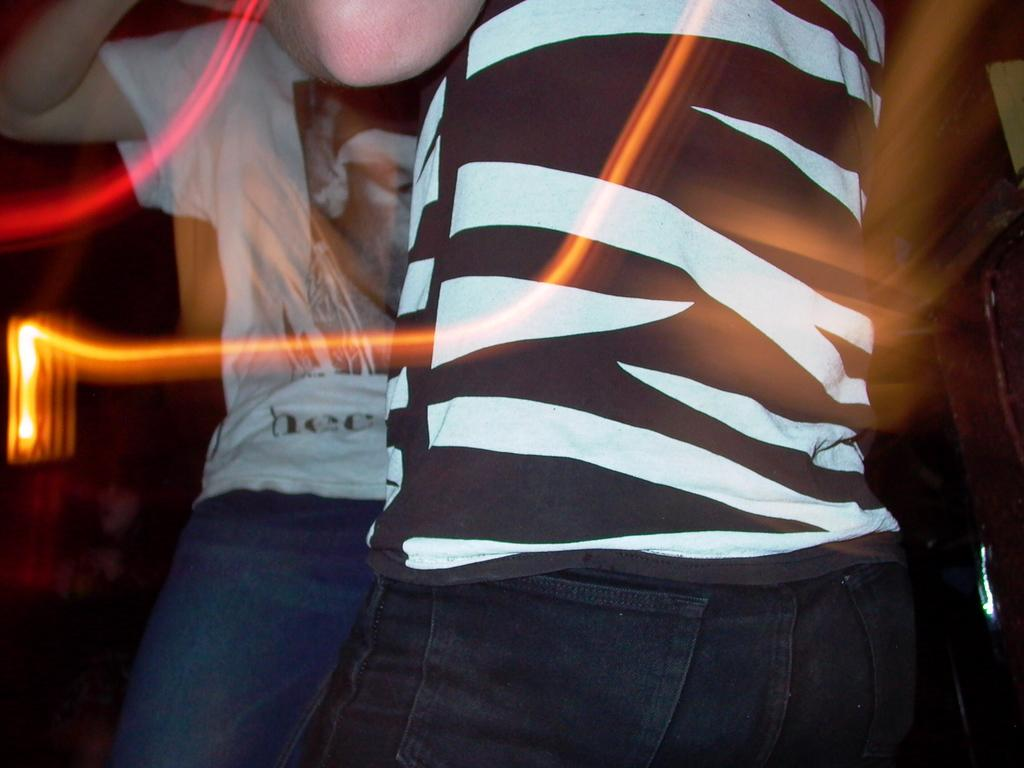How many people are in the image? There are two persons in the image. What objects resemble lights in the image? There are two objects that look like lights in the image. What can be seen in the background of the image? There are objects in the background of the image. How would you describe the overall lighting in the image? The image is dark. What type of twig can be seen in the image? There is no twig present in the image. How many feathers are visible in the image? There are no feathers visible in the image. 